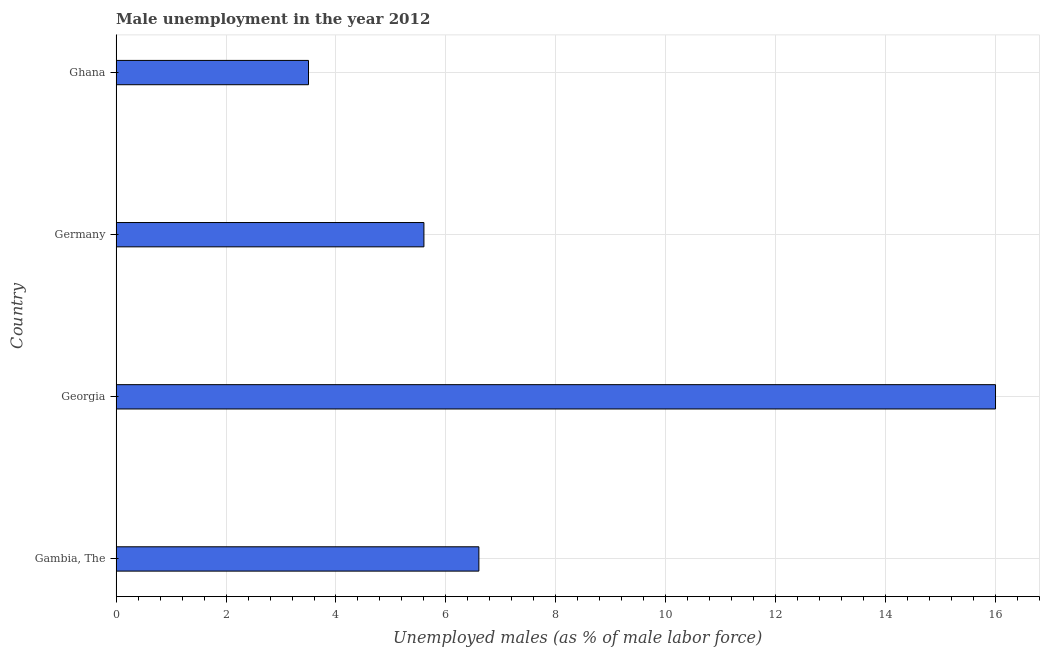Does the graph contain grids?
Offer a terse response. Yes. What is the title of the graph?
Your answer should be compact. Male unemployment in the year 2012. What is the label or title of the X-axis?
Your answer should be compact. Unemployed males (as % of male labor force). What is the label or title of the Y-axis?
Offer a terse response. Country. What is the unemployed males population in Ghana?
Give a very brief answer. 3.5. Across all countries, what is the maximum unemployed males population?
Keep it short and to the point. 16. Across all countries, what is the minimum unemployed males population?
Your response must be concise. 3.5. In which country was the unemployed males population maximum?
Your response must be concise. Georgia. In which country was the unemployed males population minimum?
Provide a succinct answer. Ghana. What is the sum of the unemployed males population?
Your answer should be very brief. 31.7. What is the difference between the unemployed males population in Gambia, The and Ghana?
Keep it short and to the point. 3.1. What is the average unemployed males population per country?
Keep it short and to the point. 7.92. What is the median unemployed males population?
Provide a short and direct response. 6.1. In how many countries, is the unemployed males population greater than 15.6 %?
Ensure brevity in your answer.  1. What is the ratio of the unemployed males population in Gambia, The to that in Georgia?
Provide a short and direct response. 0.41. Is the unemployed males population in Gambia, The less than that in Germany?
Your response must be concise. No. Is the difference between the unemployed males population in Gambia, The and Ghana greater than the difference between any two countries?
Provide a short and direct response. No. What is the difference between the highest and the second highest unemployed males population?
Offer a very short reply. 9.4. In how many countries, is the unemployed males population greater than the average unemployed males population taken over all countries?
Provide a short and direct response. 1. How many bars are there?
Your answer should be very brief. 4. Are the values on the major ticks of X-axis written in scientific E-notation?
Your response must be concise. No. What is the Unemployed males (as % of male labor force) in Gambia, The?
Provide a succinct answer. 6.6. What is the Unemployed males (as % of male labor force) of Germany?
Keep it short and to the point. 5.6. What is the Unemployed males (as % of male labor force) in Ghana?
Provide a succinct answer. 3.5. What is the difference between the Unemployed males (as % of male labor force) in Georgia and Germany?
Ensure brevity in your answer.  10.4. What is the difference between the Unemployed males (as % of male labor force) in Georgia and Ghana?
Provide a succinct answer. 12.5. What is the difference between the Unemployed males (as % of male labor force) in Germany and Ghana?
Your response must be concise. 2.1. What is the ratio of the Unemployed males (as % of male labor force) in Gambia, The to that in Georgia?
Keep it short and to the point. 0.41. What is the ratio of the Unemployed males (as % of male labor force) in Gambia, The to that in Germany?
Make the answer very short. 1.18. What is the ratio of the Unemployed males (as % of male labor force) in Gambia, The to that in Ghana?
Provide a succinct answer. 1.89. What is the ratio of the Unemployed males (as % of male labor force) in Georgia to that in Germany?
Offer a very short reply. 2.86. What is the ratio of the Unemployed males (as % of male labor force) in Georgia to that in Ghana?
Ensure brevity in your answer.  4.57. 